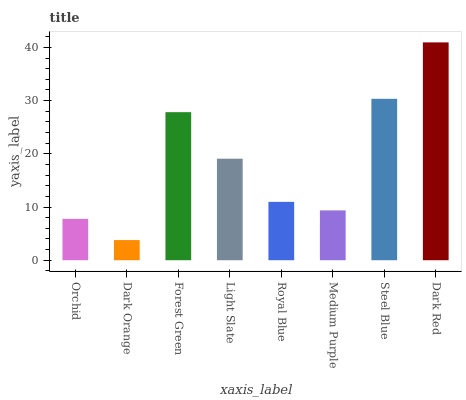Is Dark Orange the minimum?
Answer yes or no. Yes. Is Dark Red the maximum?
Answer yes or no. Yes. Is Forest Green the minimum?
Answer yes or no. No. Is Forest Green the maximum?
Answer yes or no. No. Is Forest Green greater than Dark Orange?
Answer yes or no. Yes. Is Dark Orange less than Forest Green?
Answer yes or no. Yes. Is Dark Orange greater than Forest Green?
Answer yes or no. No. Is Forest Green less than Dark Orange?
Answer yes or no. No. Is Light Slate the high median?
Answer yes or no. Yes. Is Royal Blue the low median?
Answer yes or no. Yes. Is Forest Green the high median?
Answer yes or no. No. Is Forest Green the low median?
Answer yes or no. No. 